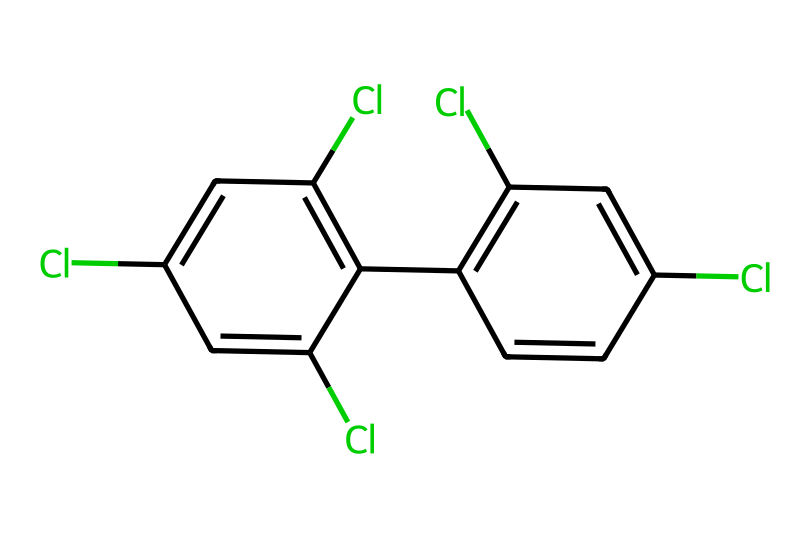What is the name of this chemical? The given SMILES corresponds to polychlorinated biphenyls (PCBs), which are compounds containing biphenyl structures with multiple chlorine substituents.
Answer: polychlorinated biphenyls How many chlorine atoms are present in the structure? By analyzing the SMILES, we can count the occurrences of "Cl," which indicates chlorine atoms. There are a total of 6 chlorines in the structure.
Answer: 6 What is the total number of carbon atoms in this chemical? By examining the structure represented by the SMILES, we can identify that there are 12 carbon atoms present in the biphenyl framework and the additional connections.
Answer: 12 Is this chemical considered a persistent organic pollutant? PCBs are classified as persistent organic pollutants because they do not easily break down in the environment and accumulate in the ecosystem.
Answer: yes What type of bond connects the carbon atoms in this compound? The carbon atoms in the biphenyl structure are connected by single and double bonds, typical of aromatic compounds, indicating a stable ring structure.
Answer: aromatic What environmental risks are associated with this chemical? PCBs pose risks such as toxicity to wildlife and humans, bioaccumulation in food chains, and potential endocrine disruption.
Answer: toxicity How does the chlorination affect the chemical properties of PCBs? Chlorination increases the hydrophobicity and stability of PCBs, making them resistant to degradation and thus more persistent in the environment.
Answer: increases stability 